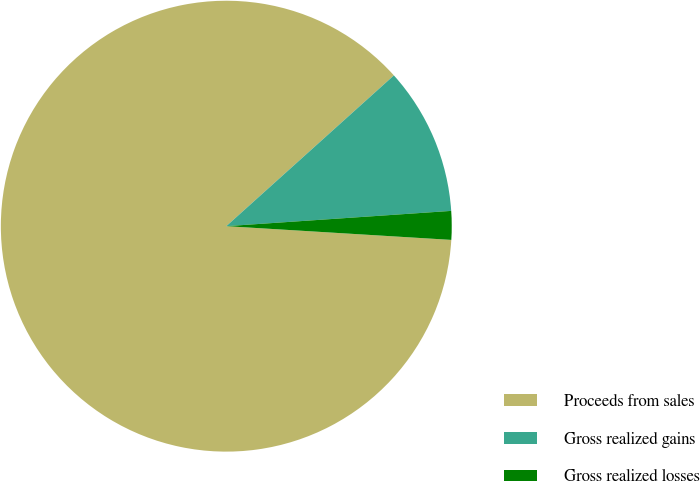Convert chart to OTSL. <chart><loc_0><loc_0><loc_500><loc_500><pie_chart><fcel>Proceeds from sales<fcel>Gross realized gains<fcel>Gross realized losses<nl><fcel>87.37%<fcel>10.58%<fcel>2.05%<nl></chart> 